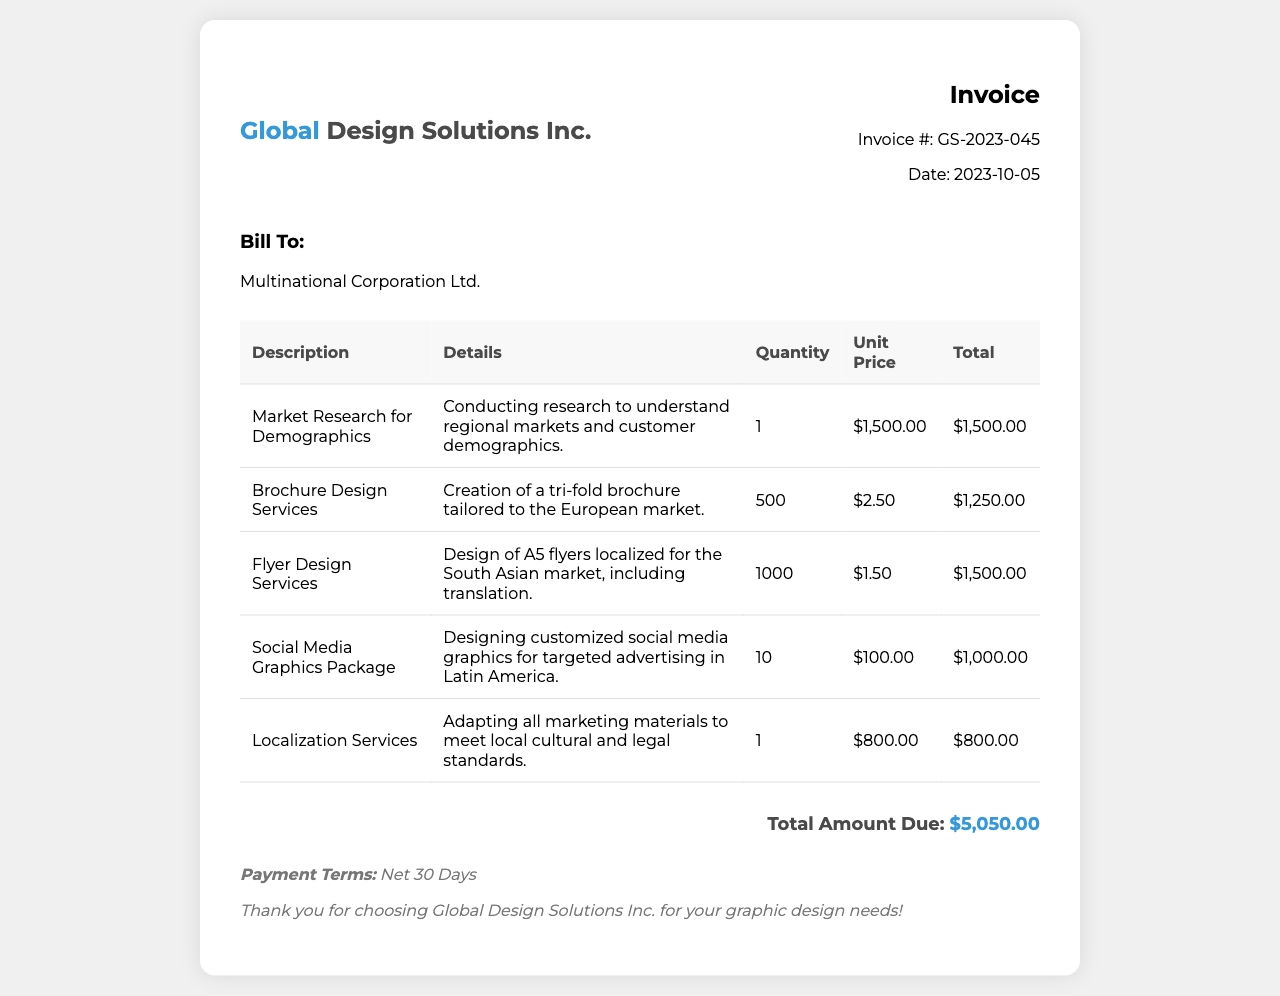What is the invoice number? The invoice number is listed in the invoice details section.
Answer: GS-2023-045 What is the total amount due? The total amount due is shown prominently at the bottom of the invoice.
Answer: $5,050.00 What date was the invoice issued? The date of the invoice is stated in the invoice details section.
Answer: 2023-10-05 How many brochures are being produced? The quantity of brochures is specified in the line item for Brochure Design Services.
Answer: 500 What service involves translation? The service that includes translation is mentioned in the description for Flyer Design Services.
Answer: Flyer Design Services What is the unit price for the Social Media Graphics Package? The unit price for Social Media Graphics Package is included in the table under Unit Price.
Answer: $100.00 What type of marketing materials are being localized? The invoice mentions adapting marketing materials to local standards under Localization Services.
Answer: All marketing materials Who is billed on this invoice? The recipient of the invoice is listed in the client information section.
Answer: Multinational Corporation Ltd 